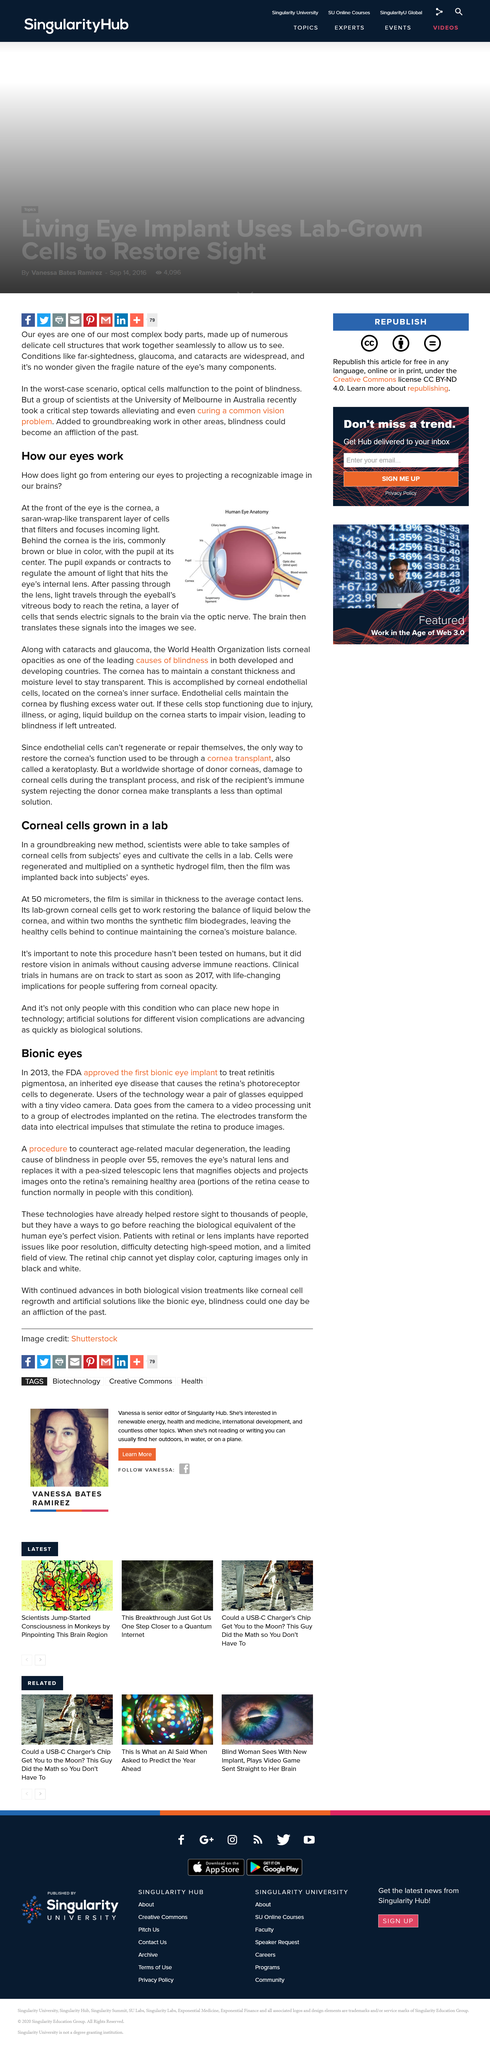Draw attention to some important aspects in this diagram. The article discusses a bionic artificial eye. The article title suggests that cells that line the cornea, also known as corneal epithelial cells, are being grown in a laboratory. The pupil expands or contracts to regulate the amount of light that hits the eye's internal lens, yes. The thickness of the film being discussed in the article is approximately 50 micrometers. Macular degeneration is the leading cause of blindness in individuals over the age of 55. 